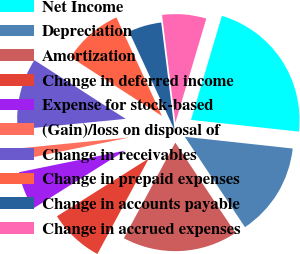Convert chart. <chart><loc_0><loc_0><loc_500><loc_500><pie_chart><fcel>Net Income<fcel>Depreciation<fcel>Amortization<fcel>Change in deferred income<fcel>Expense for stock-based<fcel>(Gain)/loss on disposal of<fcel>Change in receivables<fcel>Change in prepaid expenses<fcel>Change in accounts payable<fcel>Change in accrued expenses<nl><fcel>22.13%<fcel>13.93%<fcel>17.21%<fcel>8.2%<fcel>5.74%<fcel>1.64%<fcel>10.66%<fcel>9.02%<fcel>4.92%<fcel>6.56%<nl></chart> 